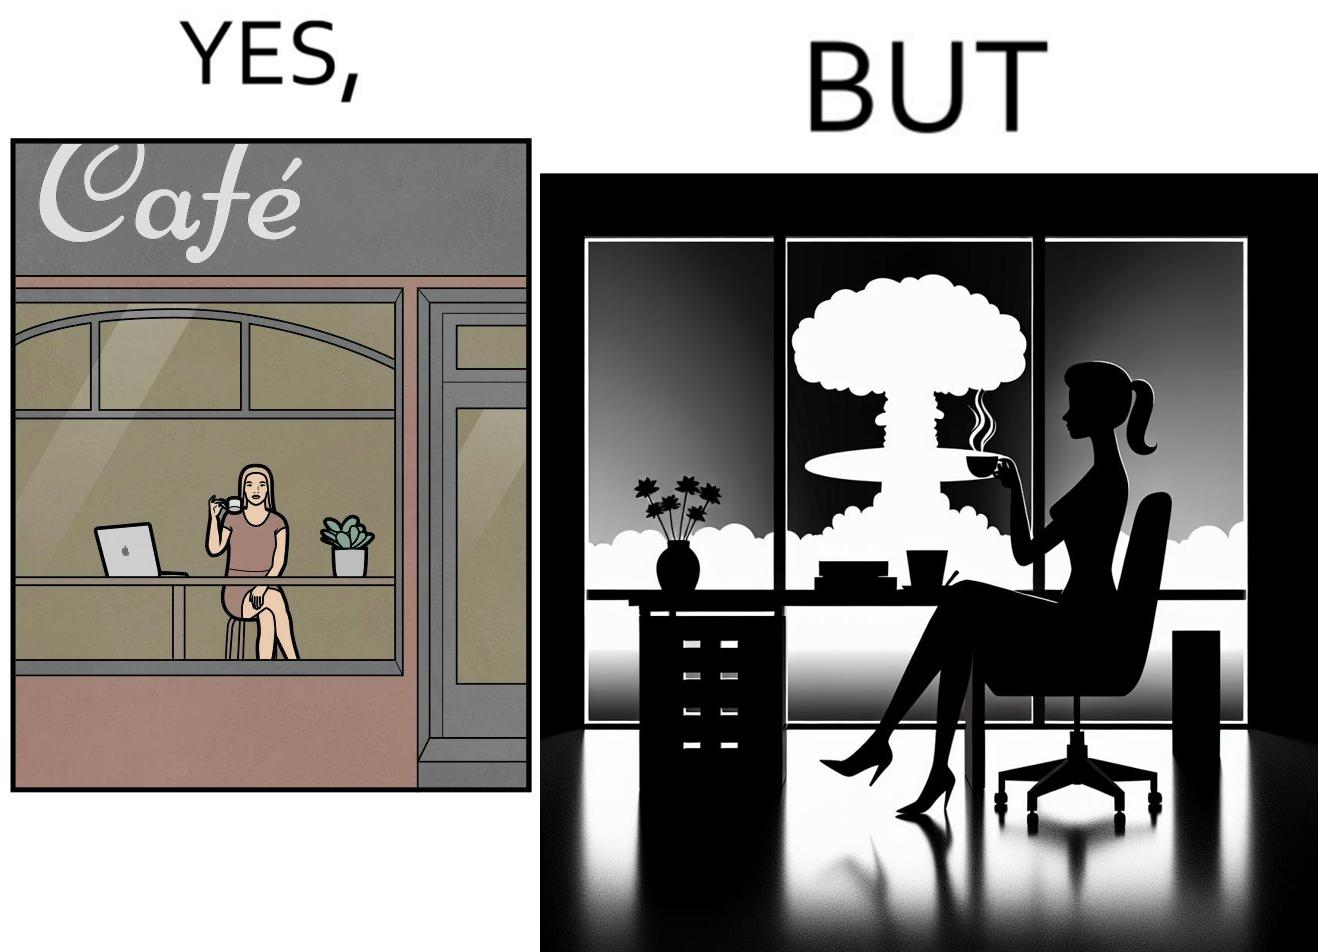Provide a description of this image. The images are funny since it shows a woman simply sipping from a cup at ease in a cafe with her laptop not caring about anything going on outside the cafe even though the situation is very grave,that is, a nuclear blast 